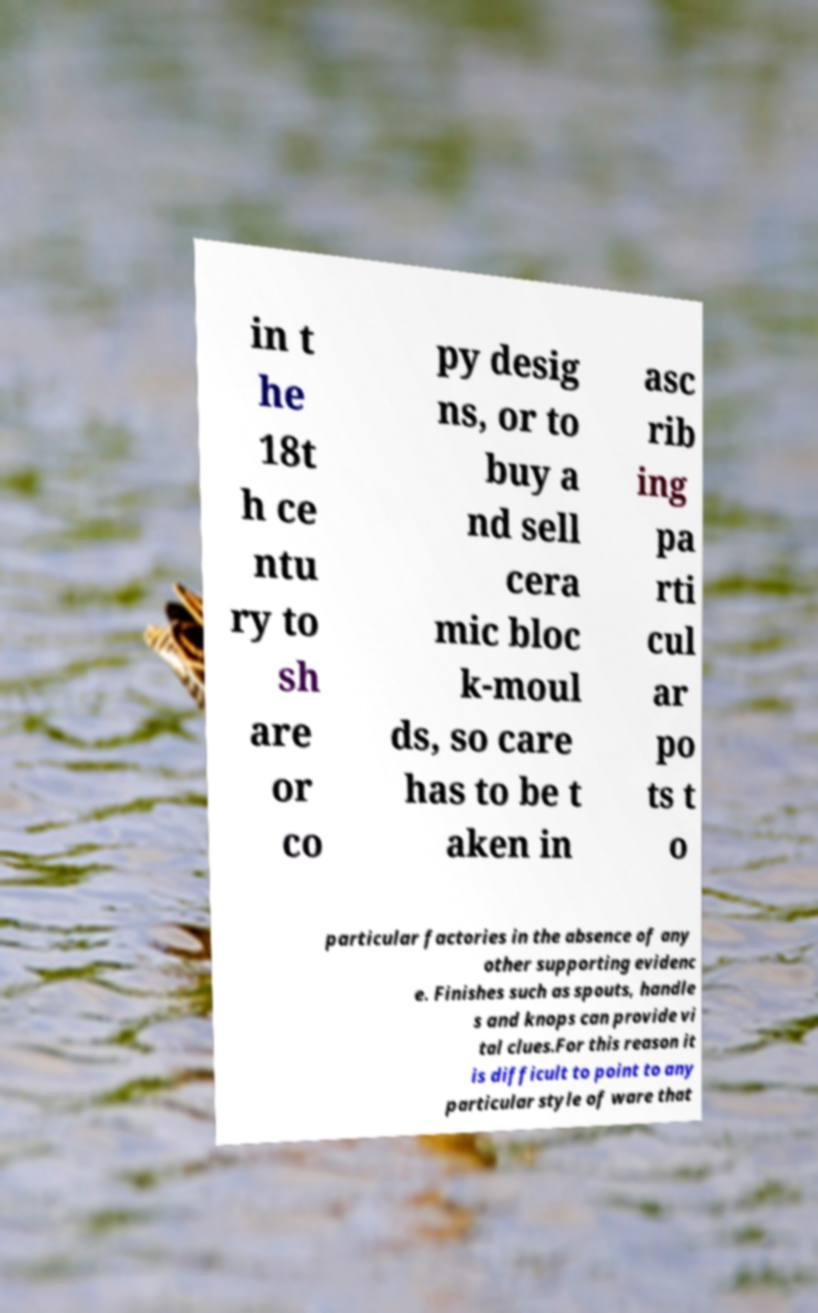There's text embedded in this image that I need extracted. Can you transcribe it verbatim? in t he 18t h ce ntu ry to sh are or co py desig ns, or to buy a nd sell cera mic bloc k-moul ds, so care has to be t aken in asc rib ing pa rti cul ar po ts t o particular factories in the absence of any other supporting evidenc e. Finishes such as spouts, handle s and knops can provide vi tal clues.For this reason it is difficult to point to any particular style of ware that 